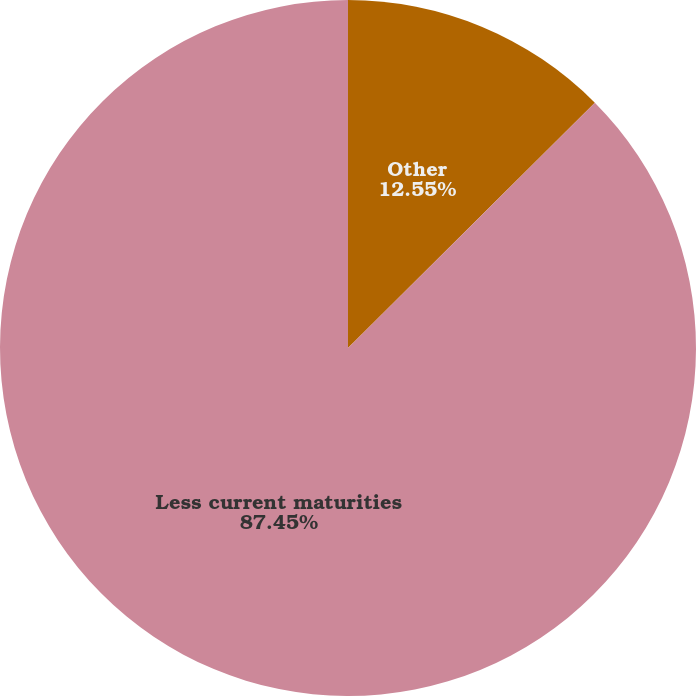Convert chart. <chart><loc_0><loc_0><loc_500><loc_500><pie_chart><fcel>Other<fcel>Less current maturities<nl><fcel>12.55%<fcel>87.45%<nl></chart> 